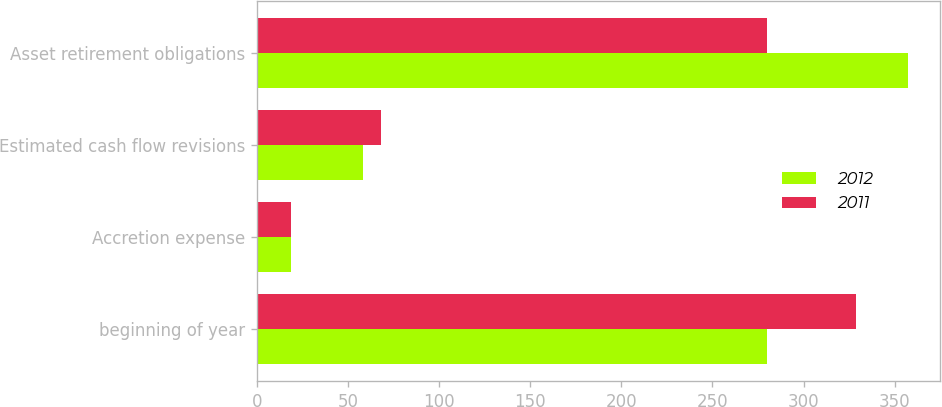Convert chart to OTSL. <chart><loc_0><loc_0><loc_500><loc_500><stacked_bar_chart><ecel><fcel>beginning of year<fcel>Accretion expense<fcel>Estimated cash flow revisions<fcel>Asset retirement obligations<nl><fcel>2012<fcel>280<fcel>19<fcel>58<fcel>357<nl><fcel>2011<fcel>329<fcel>19<fcel>68<fcel>280<nl></chart> 